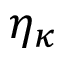<formula> <loc_0><loc_0><loc_500><loc_500>\eta _ { \kappa }</formula> 